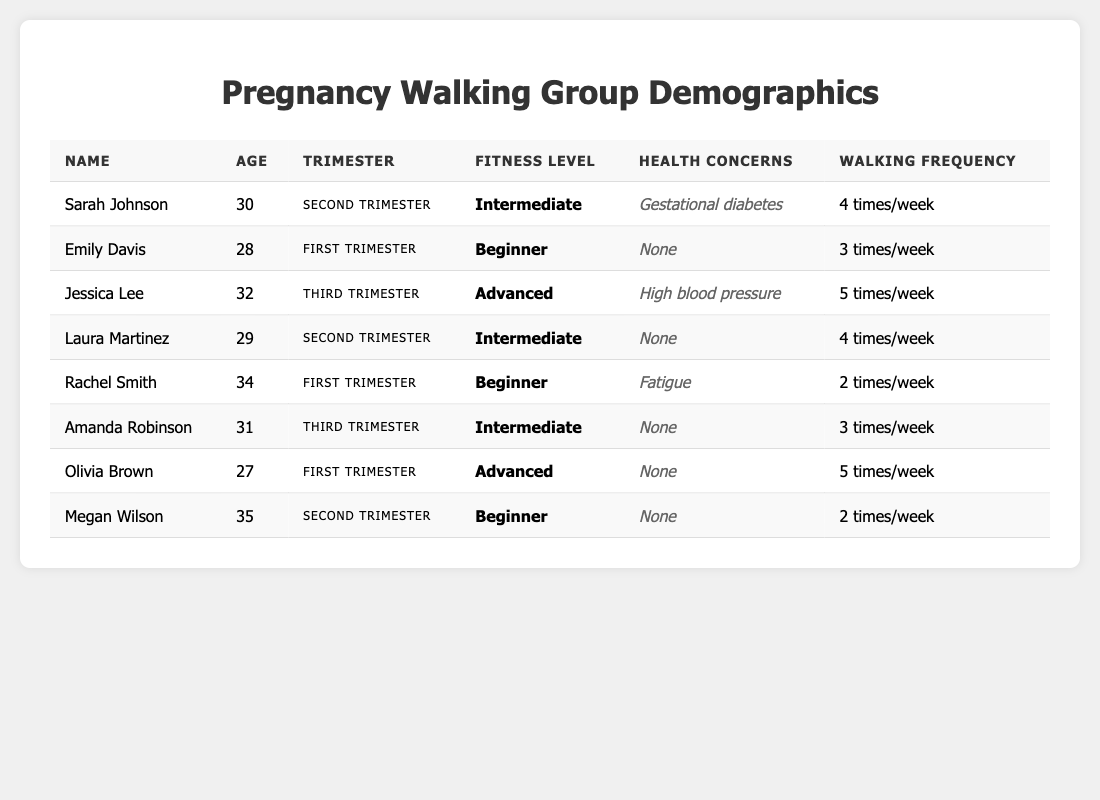What is the age of the oldest participant in the walking group? By examining the "Age" column in the table, I identify the ages of all participants: 30, 28, 32, 29, 34, 31, 27, and 35. The maximum age is 35.
Answer: 35 How many participants have a "Beginner" fitness level? From the table, I count the instances of "Beginner" in the "Fitness Level" column. The participants Emily Davis, Rachel Smith, and Megan Wilson fit this category. There are three.
Answer: 3 What is the total walking frequency per week of all participants? I sum the walking frequencies listed in the table: 4 (Sarah) + 3 (Emily) + 5 (Jessica) + 4 (Laura) + 2 (Rachel) + 3 (Amanda) + 5 (Olivia) + 2 (Megan) = 28. Therefore, the total walking frequency per week is 28.
Answer: 28 Which participant has health concerns related to high blood pressure? Looking through the "Health Concerns" column, I find that Jessica Lee has health concerns related to high blood pressure.
Answer: Jessica Lee What is the average age of participants in their first trimester? The ages of first-trimester participants (Emily Davis, Rachel Smith, and Olivia Brown) are 28, 34, and 27. I calculate the average: (28 + 34 + 27) / 3 = 29.67, rounding to two decimal places gives approximately 29.67.
Answer: 29.67 Are there any participants who walk 5 times a week? I check the "Walking Frequency" column and confirm that both Jessica Lee and Olivia Brown walk 5 times a week, so the statement is true.
Answer: Yes How many participants are in the second trimester and walk more than 3 times a week? I look at participants in the "Second Trimester" who walk more than 3 times. Sarah Johnson and Laura Martinez walk 4 times a week, making 2 participants.
Answer: 2 What health concerns do participants have in the third trimester? In the "Health Concerns" column, I identify that Jessica Lee has high blood pressure and Amanda Robinson has no health concerns. Therefore, one participant has health concerns, while another does not.
Answer: Jessica Lee has high blood pressure; Amanda Robinson has no concerns What is the difference between the number of participants in their first trimester and those in their third trimester? There are three participants in the first trimester (Emily Davis, Rachel Smith, and Olivia Brown) and two participants in the third trimester (Jessica Lee and Amanda Robinson). The difference is 3 - 2 = 1.
Answer: 1 Which fitness level is most common among participants in the second trimester? I review the "Fitness Level" for the two participants in the second trimester: Sarah Johnson (Intermediate) and Laura Martinez (Intermediate). Both have an Intermediate fitness level, confirming it as the most common.
Answer: Intermediate 